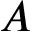<formula> <loc_0><loc_0><loc_500><loc_500>A</formula> 